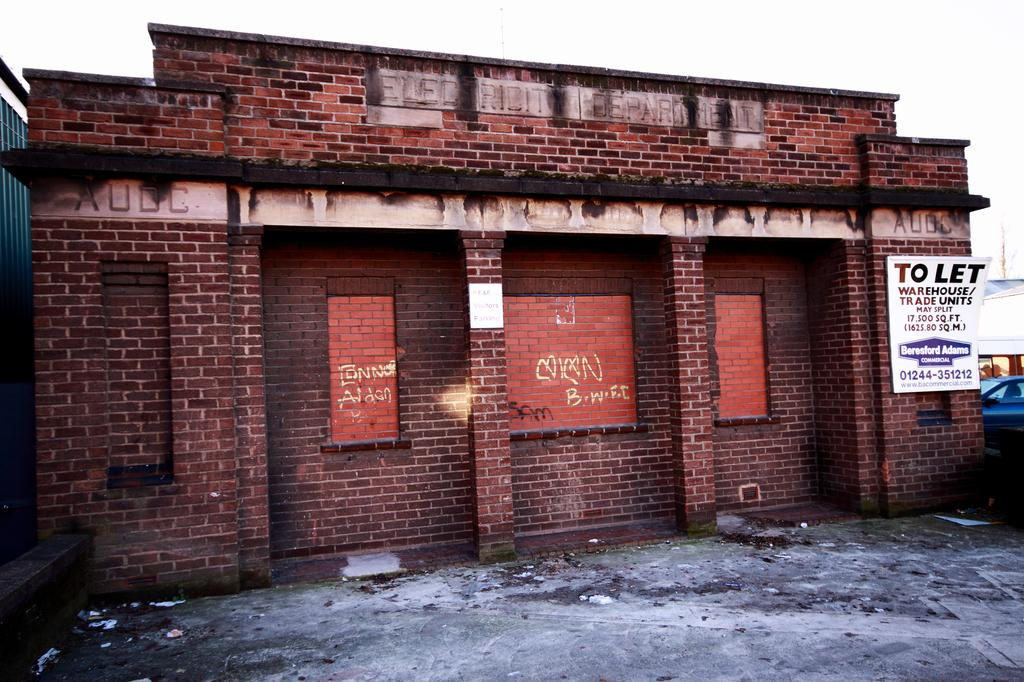What type of structure is visible in the image? There is a building in the image. What is written or displayed on the board in the image? There is a board with text in the image. Where is the car located in the image? The car is on the right side of the image. What color is the object on the left side of the image? The object on the left side of the image is green in color. How many women are present in the image? There is no information about women in the image, as the facts provided do not mention any. In which direction is the earth located in the image? The earth is not present in the image, so it is not possible to determine its location. 